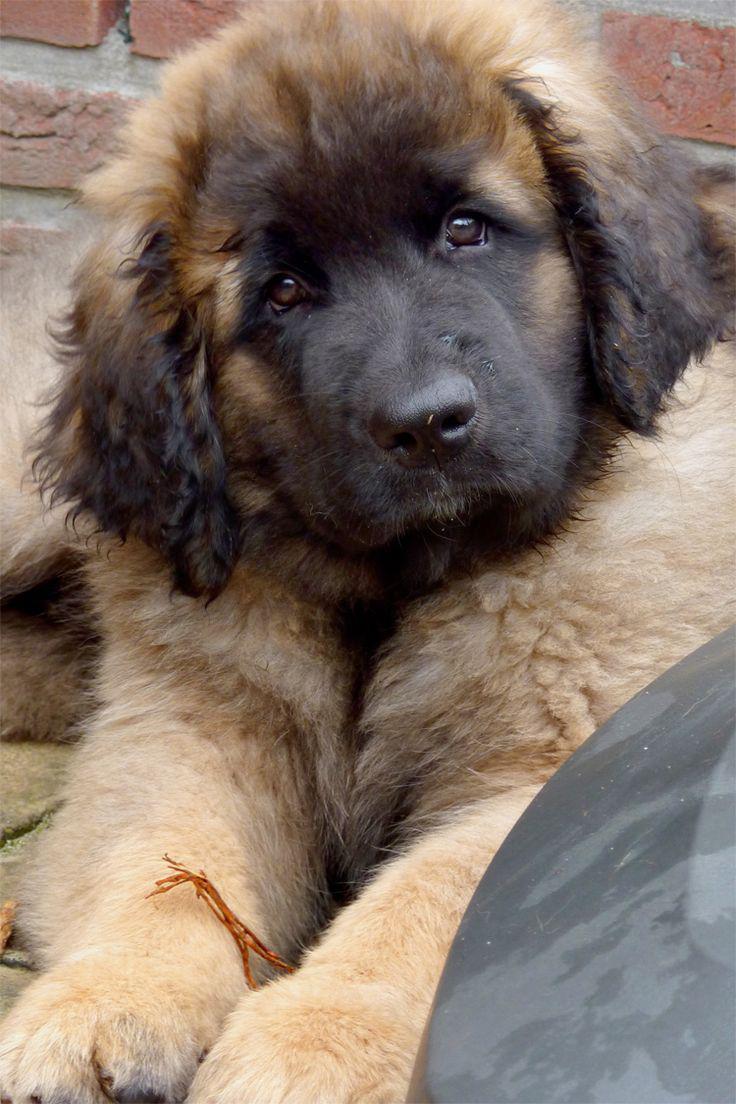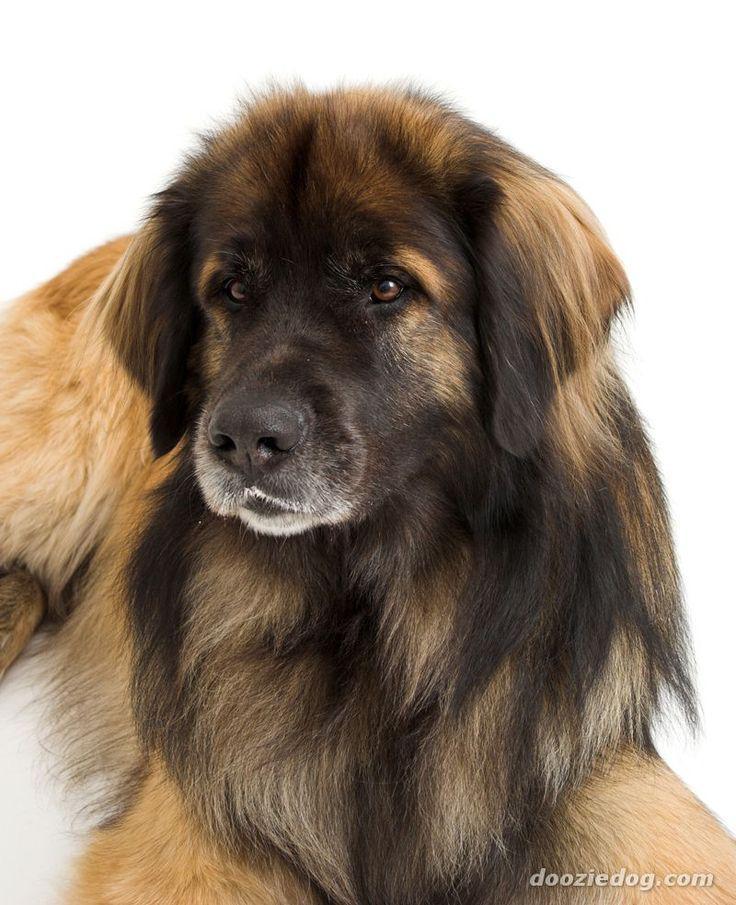The first image is the image on the left, the second image is the image on the right. Given the left and right images, does the statement "At least one dog is laying down." hold true? Answer yes or no. Yes. 